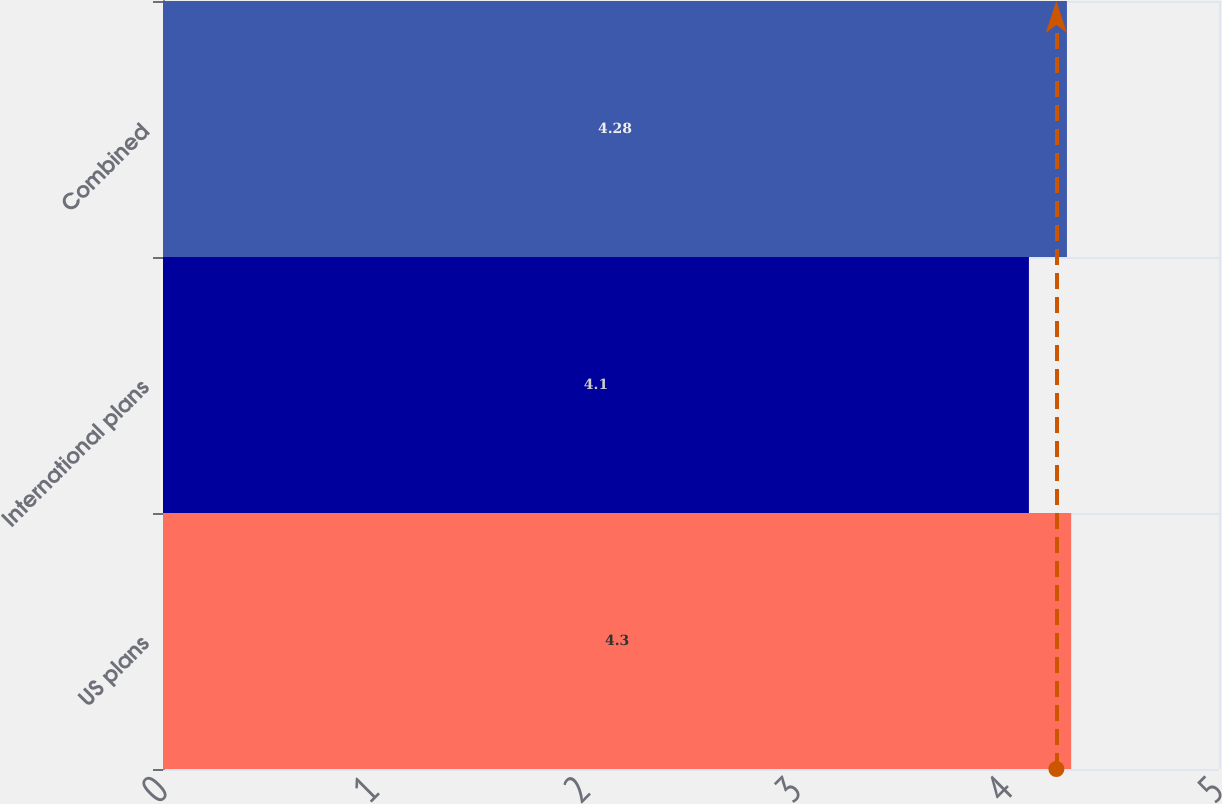Convert chart to OTSL. <chart><loc_0><loc_0><loc_500><loc_500><bar_chart><fcel>US plans<fcel>International plans<fcel>Combined<nl><fcel>4.3<fcel>4.1<fcel>4.28<nl></chart> 